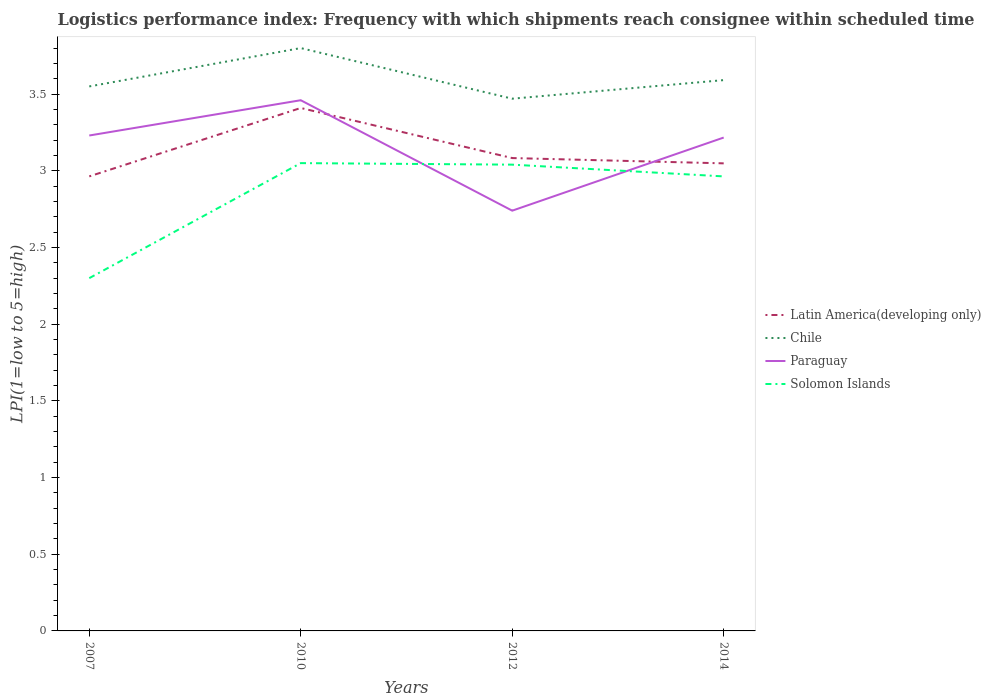Is the number of lines equal to the number of legend labels?
Make the answer very short. Yes. What is the total logistics performance index in Solomon Islands in the graph?
Make the answer very short. -0.66. What is the difference between the highest and the second highest logistics performance index in Solomon Islands?
Your answer should be compact. 0.75. What is the difference between the highest and the lowest logistics performance index in Chile?
Ensure brevity in your answer.  1. How many lines are there?
Give a very brief answer. 4. What is the difference between two consecutive major ticks on the Y-axis?
Your answer should be compact. 0.5. Does the graph contain any zero values?
Keep it short and to the point. No. Does the graph contain grids?
Keep it short and to the point. No. Where does the legend appear in the graph?
Provide a short and direct response. Center right. How many legend labels are there?
Offer a very short reply. 4. How are the legend labels stacked?
Your response must be concise. Vertical. What is the title of the graph?
Your answer should be compact. Logistics performance index: Frequency with which shipments reach consignee within scheduled time. Does "Georgia" appear as one of the legend labels in the graph?
Your response must be concise. No. What is the label or title of the Y-axis?
Keep it short and to the point. LPI(1=low to 5=high). What is the LPI(1=low to 5=high) of Latin America(developing only) in 2007?
Make the answer very short. 2.96. What is the LPI(1=low to 5=high) in Chile in 2007?
Offer a terse response. 3.55. What is the LPI(1=low to 5=high) of Paraguay in 2007?
Your answer should be compact. 3.23. What is the LPI(1=low to 5=high) of Solomon Islands in 2007?
Offer a terse response. 2.3. What is the LPI(1=low to 5=high) in Latin America(developing only) in 2010?
Offer a very short reply. 3.41. What is the LPI(1=low to 5=high) of Paraguay in 2010?
Your answer should be very brief. 3.46. What is the LPI(1=low to 5=high) of Solomon Islands in 2010?
Offer a very short reply. 3.05. What is the LPI(1=low to 5=high) in Latin America(developing only) in 2012?
Ensure brevity in your answer.  3.08. What is the LPI(1=low to 5=high) of Chile in 2012?
Offer a very short reply. 3.47. What is the LPI(1=low to 5=high) of Paraguay in 2012?
Offer a very short reply. 2.74. What is the LPI(1=low to 5=high) of Solomon Islands in 2012?
Offer a terse response. 3.04. What is the LPI(1=low to 5=high) in Latin America(developing only) in 2014?
Your answer should be very brief. 3.05. What is the LPI(1=low to 5=high) in Chile in 2014?
Your response must be concise. 3.59. What is the LPI(1=low to 5=high) in Paraguay in 2014?
Your response must be concise. 3.22. What is the LPI(1=low to 5=high) of Solomon Islands in 2014?
Provide a succinct answer. 2.96. Across all years, what is the maximum LPI(1=low to 5=high) in Latin America(developing only)?
Keep it short and to the point. 3.41. Across all years, what is the maximum LPI(1=low to 5=high) in Chile?
Provide a succinct answer. 3.8. Across all years, what is the maximum LPI(1=low to 5=high) of Paraguay?
Provide a short and direct response. 3.46. Across all years, what is the maximum LPI(1=low to 5=high) in Solomon Islands?
Ensure brevity in your answer.  3.05. Across all years, what is the minimum LPI(1=low to 5=high) in Latin America(developing only)?
Keep it short and to the point. 2.96. Across all years, what is the minimum LPI(1=low to 5=high) in Chile?
Provide a short and direct response. 3.47. Across all years, what is the minimum LPI(1=low to 5=high) of Paraguay?
Your answer should be compact. 2.74. What is the total LPI(1=low to 5=high) of Latin America(developing only) in the graph?
Provide a short and direct response. 12.5. What is the total LPI(1=low to 5=high) of Chile in the graph?
Offer a terse response. 14.41. What is the total LPI(1=low to 5=high) in Paraguay in the graph?
Your response must be concise. 12.65. What is the total LPI(1=low to 5=high) of Solomon Islands in the graph?
Make the answer very short. 11.35. What is the difference between the LPI(1=low to 5=high) of Latin America(developing only) in 2007 and that in 2010?
Provide a short and direct response. -0.45. What is the difference between the LPI(1=low to 5=high) of Paraguay in 2007 and that in 2010?
Your answer should be compact. -0.23. What is the difference between the LPI(1=low to 5=high) of Solomon Islands in 2007 and that in 2010?
Provide a short and direct response. -0.75. What is the difference between the LPI(1=low to 5=high) of Latin America(developing only) in 2007 and that in 2012?
Your response must be concise. -0.12. What is the difference between the LPI(1=low to 5=high) in Paraguay in 2007 and that in 2012?
Your answer should be very brief. 0.49. What is the difference between the LPI(1=low to 5=high) in Solomon Islands in 2007 and that in 2012?
Your answer should be very brief. -0.74. What is the difference between the LPI(1=low to 5=high) in Latin America(developing only) in 2007 and that in 2014?
Make the answer very short. -0.08. What is the difference between the LPI(1=low to 5=high) in Chile in 2007 and that in 2014?
Your response must be concise. -0.04. What is the difference between the LPI(1=low to 5=high) of Paraguay in 2007 and that in 2014?
Offer a very short reply. 0.01. What is the difference between the LPI(1=low to 5=high) in Solomon Islands in 2007 and that in 2014?
Provide a succinct answer. -0.66. What is the difference between the LPI(1=low to 5=high) in Latin America(developing only) in 2010 and that in 2012?
Keep it short and to the point. 0.33. What is the difference between the LPI(1=low to 5=high) of Chile in 2010 and that in 2012?
Provide a succinct answer. 0.33. What is the difference between the LPI(1=low to 5=high) of Paraguay in 2010 and that in 2012?
Offer a terse response. 0.72. What is the difference between the LPI(1=low to 5=high) in Latin America(developing only) in 2010 and that in 2014?
Provide a short and direct response. 0.36. What is the difference between the LPI(1=low to 5=high) of Chile in 2010 and that in 2014?
Offer a terse response. 0.21. What is the difference between the LPI(1=low to 5=high) in Paraguay in 2010 and that in 2014?
Give a very brief answer. 0.24. What is the difference between the LPI(1=low to 5=high) in Solomon Islands in 2010 and that in 2014?
Give a very brief answer. 0.09. What is the difference between the LPI(1=low to 5=high) of Latin America(developing only) in 2012 and that in 2014?
Ensure brevity in your answer.  0.03. What is the difference between the LPI(1=low to 5=high) in Chile in 2012 and that in 2014?
Offer a terse response. -0.12. What is the difference between the LPI(1=low to 5=high) of Paraguay in 2012 and that in 2014?
Provide a succinct answer. -0.48. What is the difference between the LPI(1=low to 5=high) in Solomon Islands in 2012 and that in 2014?
Provide a succinct answer. 0.08. What is the difference between the LPI(1=low to 5=high) in Latin America(developing only) in 2007 and the LPI(1=low to 5=high) in Chile in 2010?
Make the answer very short. -0.84. What is the difference between the LPI(1=low to 5=high) of Latin America(developing only) in 2007 and the LPI(1=low to 5=high) of Paraguay in 2010?
Provide a short and direct response. -0.5. What is the difference between the LPI(1=low to 5=high) of Latin America(developing only) in 2007 and the LPI(1=low to 5=high) of Solomon Islands in 2010?
Provide a succinct answer. -0.09. What is the difference between the LPI(1=low to 5=high) in Chile in 2007 and the LPI(1=low to 5=high) in Paraguay in 2010?
Offer a very short reply. 0.09. What is the difference between the LPI(1=low to 5=high) of Chile in 2007 and the LPI(1=low to 5=high) of Solomon Islands in 2010?
Your answer should be compact. 0.5. What is the difference between the LPI(1=low to 5=high) of Paraguay in 2007 and the LPI(1=low to 5=high) of Solomon Islands in 2010?
Provide a succinct answer. 0.18. What is the difference between the LPI(1=low to 5=high) of Latin America(developing only) in 2007 and the LPI(1=low to 5=high) of Chile in 2012?
Your answer should be compact. -0.51. What is the difference between the LPI(1=low to 5=high) of Latin America(developing only) in 2007 and the LPI(1=low to 5=high) of Paraguay in 2012?
Keep it short and to the point. 0.22. What is the difference between the LPI(1=low to 5=high) in Latin America(developing only) in 2007 and the LPI(1=low to 5=high) in Solomon Islands in 2012?
Ensure brevity in your answer.  -0.08. What is the difference between the LPI(1=low to 5=high) in Chile in 2007 and the LPI(1=low to 5=high) in Paraguay in 2012?
Your response must be concise. 0.81. What is the difference between the LPI(1=low to 5=high) of Chile in 2007 and the LPI(1=low to 5=high) of Solomon Islands in 2012?
Give a very brief answer. 0.51. What is the difference between the LPI(1=low to 5=high) of Paraguay in 2007 and the LPI(1=low to 5=high) of Solomon Islands in 2012?
Your response must be concise. 0.19. What is the difference between the LPI(1=low to 5=high) in Latin America(developing only) in 2007 and the LPI(1=low to 5=high) in Chile in 2014?
Your response must be concise. -0.63. What is the difference between the LPI(1=low to 5=high) of Latin America(developing only) in 2007 and the LPI(1=low to 5=high) of Paraguay in 2014?
Your answer should be very brief. -0.25. What is the difference between the LPI(1=low to 5=high) of Latin America(developing only) in 2007 and the LPI(1=low to 5=high) of Solomon Islands in 2014?
Your answer should be compact. 0. What is the difference between the LPI(1=low to 5=high) in Chile in 2007 and the LPI(1=low to 5=high) in Solomon Islands in 2014?
Offer a terse response. 0.59. What is the difference between the LPI(1=low to 5=high) of Paraguay in 2007 and the LPI(1=low to 5=high) of Solomon Islands in 2014?
Your answer should be very brief. 0.27. What is the difference between the LPI(1=low to 5=high) of Latin America(developing only) in 2010 and the LPI(1=low to 5=high) of Chile in 2012?
Give a very brief answer. -0.06. What is the difference between the LPI(1=low to 5=high) of Latin America(developing only) in 2010 and the LPI(1=low to 5=high) of Paraguay in 2012?
Your answer should be very brief. 0.67. What is the difference between the LPI(1=low to 5=high) in Latin America(developing only) in 2010 and the LPI(1=low to 5=high) in Solomon Islands in 2012?
Offer a terse response. 0.37. What is the difference between the LPI(1=low to 5=high) in Chile in 2010 and the LPI(1=low to 5=high) in Paraguay in 2012?
Offer a very short reply. 1.06. What is the difference between the LPI(1=low to 5=high) of Chile in 2010 and the LPI(1=low to 5=high) of Solomon Islands in 2012?
Offer a very short reply. 0.76. What is the difference between the LPI(1=low to 5=high) in Paraguay in 2010 and the LPI(1=low to 5=high) in Solomon Islands in 2012?
Make the answer very short. 0.42. What is the difference between the LPI(1=low to 5=high) of Latin America(developing only) in 2010 and the LPI(1=low to 5=high) of Chile in 2014?
Ensure brevity in your answer.  -0.18. What is the difference between the LPI(1=low to 5=high) of Latin America(developing only) in 2010 and the LPI(1=low to 5=high) of Paraguay in 2014?
Give a very brief answer. 0.19. What is the difference between the LPI(1=low to 5=high) in Latin America(developing only) in 2010 and the LPI(1=low to 5=high) in Solomon Islands in 2014?
Ensure brevity in your answer.  0.45. What is the difference between the LPI(1=low to 5=high) of Chile in 2010 and the LPI(1=low to 5=high) of Paraguay in 2014?
Your answer should be compact. 0.58. What is the difference between the LPI(1=low to 5=high) of Chile in 2010 and the LPI(1=low to 5=high) of Solomon Islands in 2014?
Keep it short and to the point. 0.84. What is the difference between the LPI(1=low to 5=high) in Paraguay in 2010 and the LPI(1=low to 5=high) in Solomon Islands in 2014?
Your answer should be compact. 0.5. What is the difference between the LPI(1=low to 5=high) in Latin America(developing only) in 2012 and the LPI(1=low to 5=high) in Chile in 2014?
Keep it short and to the point. -0.51. What is the difference between the LPI(1=low to 5=high) in Latin America(developing only) in 2012 and the LPI(1=low to 5=high) in Paraguay in 2014?
Ensure brevity in your answer.  -0.13. What is the difference between the LPI(1=low to 5=high) of Latin America(developing only) in 2012 and the LPI(1=low to 5=high) of Solomon Islands in 2014?
Offer a very short reply. 0.12. What is the difference between the LPI(1=low to 5=high) in Chile in 2012 and the LPI(1=low to 5=high) in Paraguay in 2014?
Make the answer very short. 0.25. What is the difference between the LPI(1=low to 5=high) of Chile in 2012 and the LPI(1=low to 5=high) of Solomon Islands in 2014?
Offer a very short reply. 0.51. What is the difference between the LPI(1=low to 5=high) of Paraguay in 2012 and the LPI(1=low to 5=high) of Solomon Islands in 2014?
Give a very brief answer. -0.22. What is the average LPI(1=low to 5=high) in Latin America(developing only) per year?
Keep it short and to the point. 3.13. What is the average LPI(1=low to 5=high) in Chile per year?
Provide a short and direct response. 3.6. What is the average LPI(1=low to 5=high) in Paraguay per year?
Your answer should be very brief. 3.16. What is the average LPI(1=low to 5=high) of Solomon Islands per year?
Keep it short and to the point. 2.84. In the year 2007, what is the difference between the LPI(1=low to 5=high) in Latin America(developing only) and LPI(1=low to 5=high) in Chile?
Make the answer very short. -0.59. In the year 2007, what is the difference between the LPI(1=low to 5=high) of Latin America(developing only) and LPI(1=low to 5=high) of Paraguay?
Offer a very short reply. -0.27. In the year 2007, what is the difference between the LPI(1=low to 5=high) in Latin America(developing only) and LPI(1=low to 5=high) in Solomon Islands?
Your answer should be very brief. 0.66. In the year 2007, what is the difference between the LPI(1=low to 5=high) in Chile and LPI(1=low to 5=high) in Paraguay?
Offer a very short reply. 0.32. In the year 2007, what is the difference between the LPI(1=low to 5=high) of Chile and LPI(1=low to 5=high) of Solomon Islands?
Make the answer very short. 1.25. In the year 2010, what is the difference between the LPI(1=low to 5=high) in Latin America(developing only) and LPI(1=low to 5=high) in Chile?
Make the answer very short. -0.39. In the year 2010, what is the difference between the LPI(1=low to 5=high) in Latin America(developing only) and LPI(1=low to 5=high) in Paraguay?
Your response must be concise. -0.05. In the year 2010, what is the difference between the LPI(1=low to 5=high) in Latin America(developing only) and LPI(1=low to 5=high) in Solomon Islands?
Offer a very short reply. 0.36. In the year 2010, what is the difference between the LPI(1=low to 5=high) in Chile and LPI(1=low to 5=high) in Paraguay?
Your response must be concise. 0.34. In the year 2010, what is the difference between the LPI(1=low to 5=high) of Paraguay and LPI(1=low to 5=high) of Solomon Islands?
Provide a succinct answer. 0.41. In the year 2012, what is the difference between the LPI(1=low to 5=high) of Latin America(developing only) and LPI(1=low to 5=high) of Chile?
Your response must be concise. -0.39. In the year 2012, what is the difference between the LPI(1=low to 5=high) in Latin America(developing only) and LPI(1=low to 5=high) in Paraguay?
Provide a succinct answer. 0.34. In the year 2012, what is the difference between the LPI(1=low to 5=high) of Latin America(developing only) and LPI(1=low to 5=high) of Solomon Islands?
Offer a very short reply. 0.04. In the year 2012, what is the difference between the LPI(1=low to 5=high) of Chile and LPI(1=low to 5=high) of Paraguay?
Offer a very short reply. 0.73. In the year 2012, what is the difference between the LPI(1=low to 5=high) of Chile and LPI(1=low to 5=high) of Solomon Islands?
Your answer should be very brief. 0.43. In the year 2012, what is the difference between the LPI(1=low to 5=high) in Paraguay and LPI(1=low to 5=high) in Solomon Islands?
Give a very brief answer. -0.3. In the year 2014, what is the difference between the LPI(1=low to 5=high) of Latin America(developing only) and LPI(1=low to 5=high) of Chile?
Offer a very short reply. -0.54. In the year 2014, what is the difference between the LPI(1=low to 5=high) in Latin America(developing only) and LPI(1=low to 5=high) in Paraguay?
Make the answer very short. -0.17. In the year 2014, what is the difference between the LPI(1=low to 5=high) in Latin America(developing only) and LPI(1=low to 5=high) in Solomon Islands?
Your response must be concise. 0.09. In the year 2014, what is the difference between the LPI(1=low to 5=high) of Chile and LPI(1=low to 5=high) of Paraguay?
Give a very brief answer. 0.37. In the year 2014, what is the difference between the LPI(1=low to 5=high) of Chile and LPI(1=low to 5=high) of Solomon Islands?
Offer a very short reply. 0.63. In the year 2014, what is the difference between the LPI(1=low to 5=high) of Paraguay and LPI(1=low to 5=high) of Solomon Islands?
Provide a short and direct response. 0.25. What is the ratio of the LPI(1=low to 5=high) in Latin America(developing only) in 2007 to that in 2010?
Your answer should be very brief. 0.87. What is the ratio of the LPI(1=low to 5=high) in Chile in 2007 to that in 2010?
Provide a succinct answer. 0.93. What is the ratio of the LPI(1=low to 5=high) of Paraguay in 2007 to that in 2010?
Keep it short and to the point. 0.93. What is the ratio of the LPI(1=low to 5=high) of Solomon Islands in 2007 to that in 2010?
Offer a terse response. 0.75. What is the ratio of the LPI(1=low to 5=high) of Latin America(developing only) in 2007 to that in 2012?
Make the answer very short. 0.96. What is the ratio of the LPI(1=low to 5=high) in Chile in 2007 to that in 2012?
Make the answer very short. 1.02. What is the ratio of the LPI(1=low to 5=high) of Paraguay in 2007 to that in 2012?
Offer a terse response. 1.18. What is the ratio of the LPI(1=low to 5=high) of Solomon Islands in 2007 to that in 2012?
Provide a succinct answer. 0.76. What is the ratio of the LPI(1=low to 5=high) of Latin America(developing only) in 2007 to that in 2014?
Offer a very short reply. 0.97. What is the ratio of the LPI(1=low to 5=high) in Chile in 2007 to that in 2014?
Give a very brief answer. 0.99. What is the ratio of the LPI(1=low to 5=high) of Paraguay in 2007 to that in 2014?
Offer a terse response. 1. What is the ratio of the LPI(1=low to 5=high) of Solomon Islands in 2007 to that in 2014?
Your answer should be very brief. 0.78. What is the ratio of the LPI(1=low to 5=high) in Latin America(developing only) in 2010 to that in 2012?
Your response must be concise. 1.11. What is the ratio of the LPI(1=low to 5=high) in Chile in 2010 to that in 2012?
Your answer should be compact. 1.1. What is the ratio of the LPI(1=low to 5=high) in Paraguay in 2010 to that in 2012?
Your answer should be very brief. 1.26. What is the ratio of the LPI(1=low to 5=high) of Solomon Islands in 2010 to that in 2012?
Your answer should be compact. 1. What is the ratio of the LPI(1=low to 5=high) of Latin America(developing only) in 2010 to that in 2014?
Make the answer very short. 1.12. What is the ratio of the LPI(1=low to 5=high) of Chile in 2010 to that in 2014?
Ensure brevity in your answer.  1.06. What is the ratio of the LPI(1=low to 5=high) in Paraguay in 2010 to that in 2014?
Give a very brief answer. 1.08. What is the ratio of the LPI(1=low to 5=high) in Solomon Islands in 2010 to that in 2014?
Your response must be concise. 1.03. What is the ratio of the LPI(1=low to 5=high) of Latin America(developing only) in 2012 to that in 2014?
Offer a terse response. 1.01. What is the ratio of the LPI(1=low to 5=high) in Chile in 2012 to that in 2014?
Offer a terse response. 0.97. What is the ratio of the LPI(1=low to 5=high) in Paraguay in 2012 to that in 2014?
Your answer should be compact. 0.85. What is the ratio of the LPI(1=low to 5=high) in Solomon Islands in 2012 to that in 2014?
Your answer should be very brief. 1.03. What is the difference between the highest and the second highest LPI(1=low to 5=high) of Latin America(developing only)?
Keep it short and to the point. 0.33. What is the difference between the highest and the second highest LPI(1=low to 5=high) in Chile?
Keep it short and to the point. 0.21. What is the difference between the highest and the second highest LPI(1=low to 5=high) in Paraguay?
Make the answer very short. 0.23. What is the difference between the highest and the second highest LPI(1=low to 5=high) in Solomon Islands?
Your response must be concise. 0.01. What is the difference between the highest and the lowest LPI(1=low to 5=high) in Latin America(developing only)?
Keep it short and to the point. 0.45. What is the difference between the highest and the lowest LPI(1=low to 5=high) of Chile?
Make the answer very short. 0.33. What is the difference between the highest and the lowest LPI(1=low to 5=high) of Paraguay?
Provide a short and direct response. 0.72. What is the difference between the highest and the lowest LPI(1=low to 5=high) in Solomon Islands?
Offer a very short reply. 0.75. 